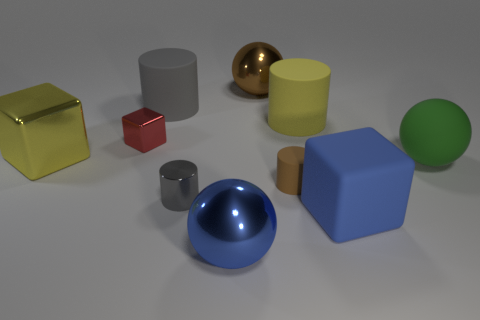Subtract all green cubes. Subtract all cyan cylinders. How many cubes are left? 3 Subtract all cylinders. How many objects are left? 6 Subtract all small brown things. Subtract all gray metal cylinders. How many objects are left? 8 Add 5 yellow matte cylinders. How many yellow matte cylinders are left? 6 Add 4 small brown metal balls. How many small brown metal balls exist? 4 Subtract 1 brown cylinders. How many objects are left? 9 